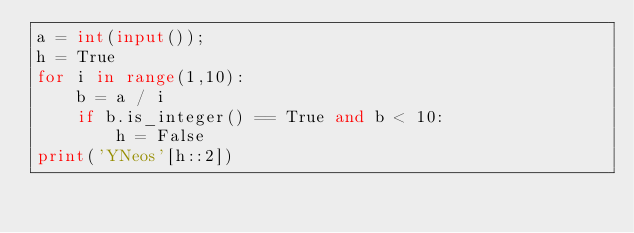Convert code to text. <code><loc_0><loc_0><loc_500><loc_500><_Python_>a = int(input());
h = True
for i in range(1,10):
    b = a / i
    if b.is_integer() == True and b < 10:
        h = False
print('YNeos'[h::2])</code> 